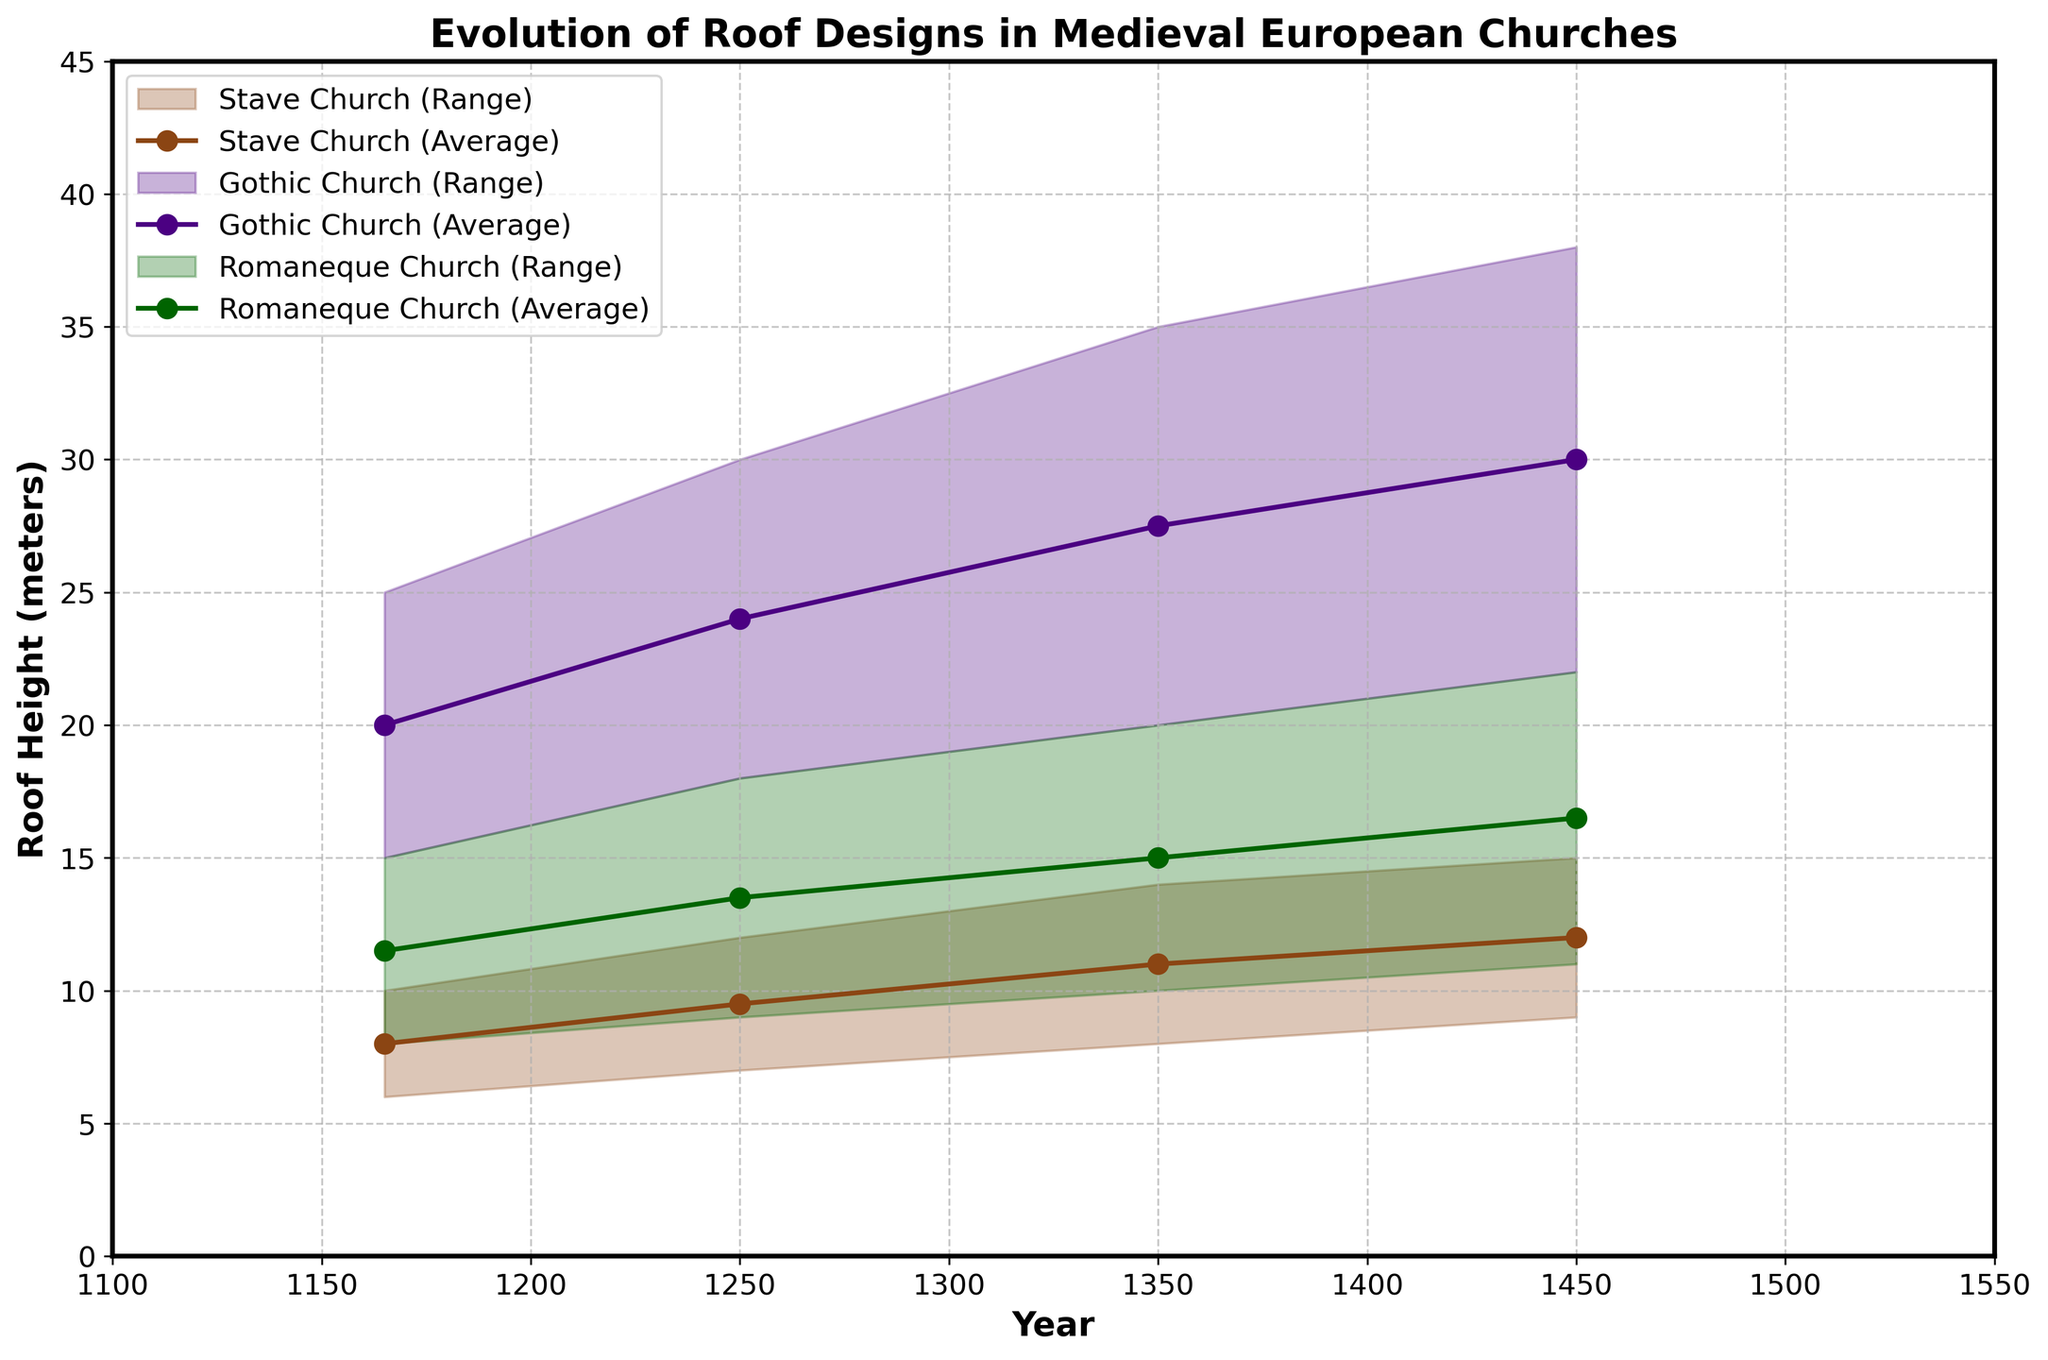What's the tallest roof design in Gothic churches from 1400 to 1500? The tallest roof design in Gothic churches from 1400 to 1500 is the Pointed Arch with Flying Buttresses. The range for this period is 22 to 38 meters, and 38 meters is the highest value seen.
Answer: 38 meters What is the height range for stave churches between 1200 and 1300? For stave churches between 1200 and 1300, the roof design listed is A-frame. The height range for this design during this period is from 7 to 12 meters, as evident from the figure.
Answer: 7 to 12 meters Comparing the average roof heights in Stave churches and Gothic churches between 1300 and 1400, which has a greater value? For stave churches between 1300 and 1400, the average roof height is (8+14)/2 = 11 meters. For Gothic churches in the same period, the average roof height is (20+35)/2 = 27.5 meters. Thus, Gothic churches have a greater average roof height during this period.
Answer: Gothic churches How does the roof height of Romanesque churches evolve from 1130 to 1500? Romanesque churches start with a range of 8 to 15 meters from 1130 to 1200. Then, it increases to a range of 9 to 18 meters from 1200 to 1300, followed by 10 to 20 meters from 1300 to 1400, and finally reaches 11 to 22 meters from 1400 to 1500. This shows a steady increase in roof height over time.
Answer: Increases steadily Which church type shows the least vertical growth in roof design from 1130 to 1500? To determine the least vertical growth, we look at the difference between the minimum and maximum heights from 1130 to 1500 for each church type. Stave churches start from 6-10 meters and end at 9-15 meters (5 meters increase). Gothic churches start from 15-25 meters and end at 22-38 meters (13 meters increase). Romanesque churches start from 8-15 meters and end at 11-22 meters (7 meters increase). Stave churches have the least vertical growth.
Answer: Stave churches What's the roof height range for Multi-tiered A-frame in stave churches during the 1400-1500 period? For stave churches during the 1400-1500 period, the roof design is Multi-tiered A-frame with a height range of 9 to 15 meters, as indicated in the figure.
Answer: 9 to 15 meters How does the roof design evolution differ between Gothic and Romanesque churches from 1300 to 1400? For Gothic churches, the roof design evolves from Pointed Arch to Pointed Arch with Flying Buttresses with a height range of 20 to 35 meters. In Romanesque churches, the design changes from Barrel Vault to Groin Vault with a height range of 10 to 20 meters. This shows that Gothic churches integrate more structural complexity and achieve greater heights.
Answer: More structural complexity and higher heights in Gothic churches 